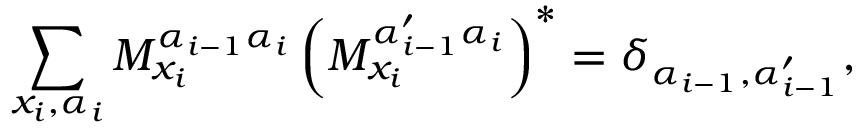<formula> <loc_0><loc_0><loc_500><loc_500>\sum _ { x _ { i } , \alpha _ { i } } M _ { x _ { i } } ^ { \alpha _ { i - 1 } \alpha _ { i } } \left ( M _ { x _ { i } } ^ { \alpha _ { i - 1 } ^ { \prime } \alpha _ { i } } \right ) ^ { * } = \delta _ { \alpha _ { i - 1 } , \alpha _ { i - 1 } ^ { \prime } } ,</formula> 